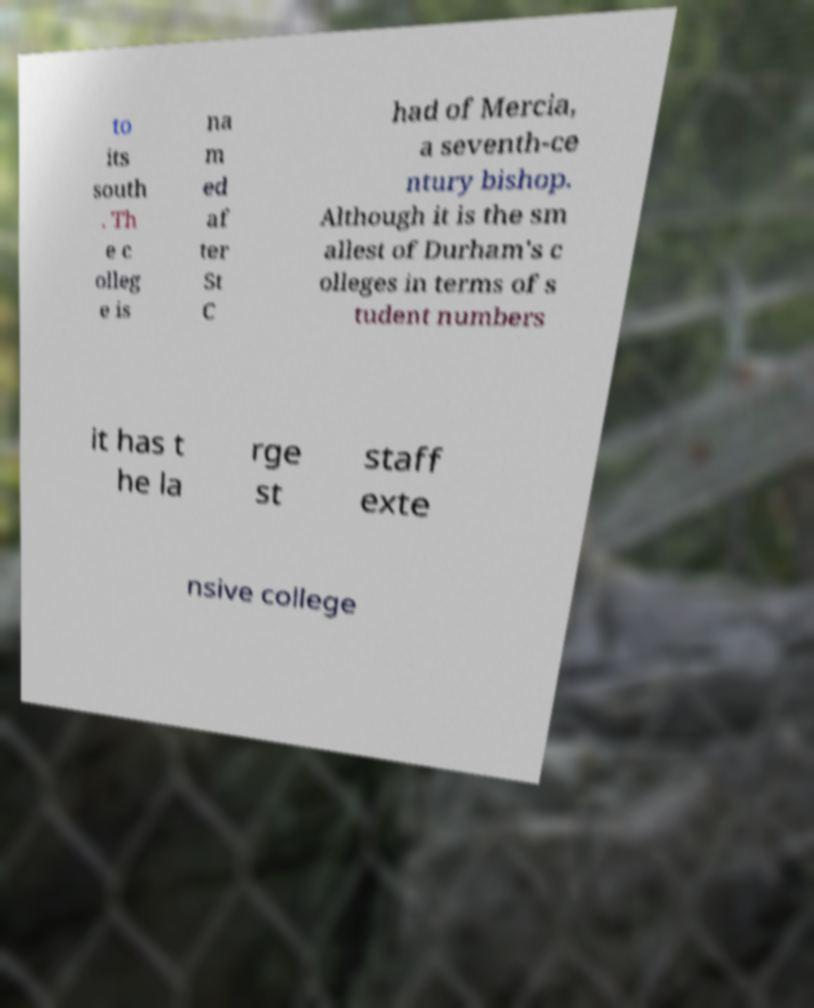Please read and relay the text visible in this image. What does it say? to its south . Th e c olleg e is na m ed af ter St C had of Mercia, a seventh-ce ntury bishop. Although it is the sm allest of Durham's c olleges in terms of s tudent numbers it has t he la rge st staff exte nsive college 